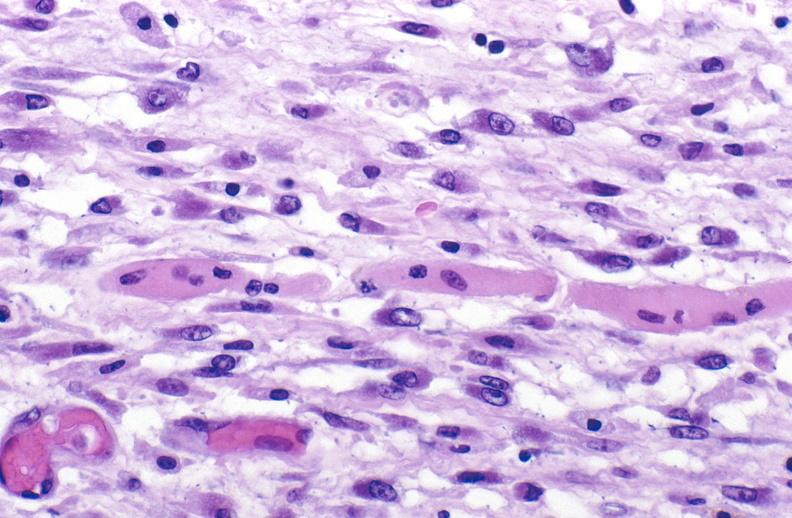s soft tissue present?
Answer the question using a single word or phrase. Yes 